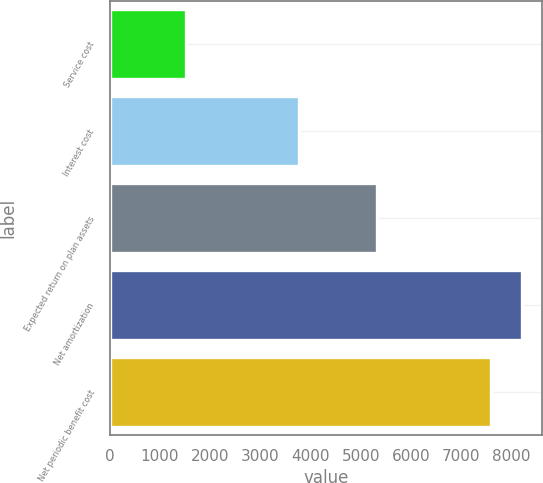Convert chart to OTSL. <chart><loc_0><loc_0><loc_500><loc_500><bar_chart><fcel>Service cost<fcel>Interest cost<fcel>Expected return on plan assets<fcel>Net amortization<fcel>Net periodic benefit cost<nl><fcel>1526<fcel>3766<fcel>5318<fcel>8204.5<fcel>7595<nl></chart> 